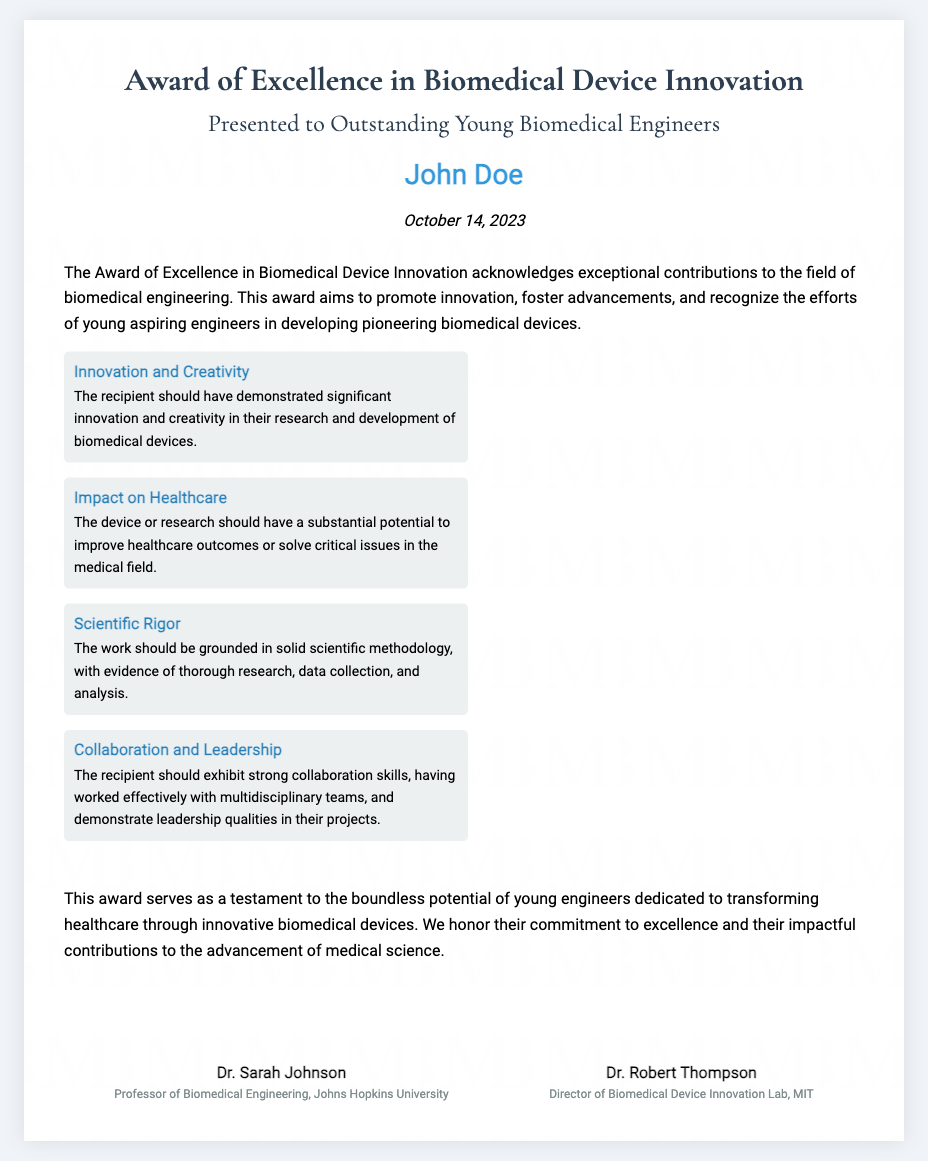What is the title of the award? The title of the award is the "Award of Excellence in Biomedical Device Innovation."
Answer: Award of Excellence in Biomedical Device Innovation Who is the recipient of the award? The recipient of the award is named "John Doe."
Answer: John Doe What is the date the award was presented? The date the award was presented is mentioned in the document as "October 14, 2023."
Answer: October 14, 2023 What is one of the criteria for the award? The criteria include "Innovation and Creativity," which is mentioned in the document.
Answer: Innovation and Creativity Which university is Dr. Sarah Johnson affiliated with? Dr. Sarah Johnson is affiliated with "Johns Hopkins University."
Answer: Johns Hopkins University What is the main purpose of the award? The main purpose of the award is to "acknowledge exceptional contributions to the field of biomedical engineering."
Answer: Acknowledge exceptional contributions What are the qualities the recipient should demonstrate? The recipient should demonstrate "collaboration skills" and "leadership qualities."
Answer: Collaboration skills, leadership qualities Who are the signatories of the certificate? The signatories are "Dr. Sarah Johnson" and "Dr. Robert Thompson."
Answer: Dr. Sarah Johnson, Dr. Robert Thompson How does this award impact young engineers? This award is a "testament to the boundless potential of young engineers."
Answer: Testament to the boundless potential 